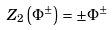<formula> <loc_0><loc_0><loc_500><loc_500>Z _ { 2 } \left ( \Phi ^ { \pm } \right ) = \pm \Phi ^ { \pm }</formula> 